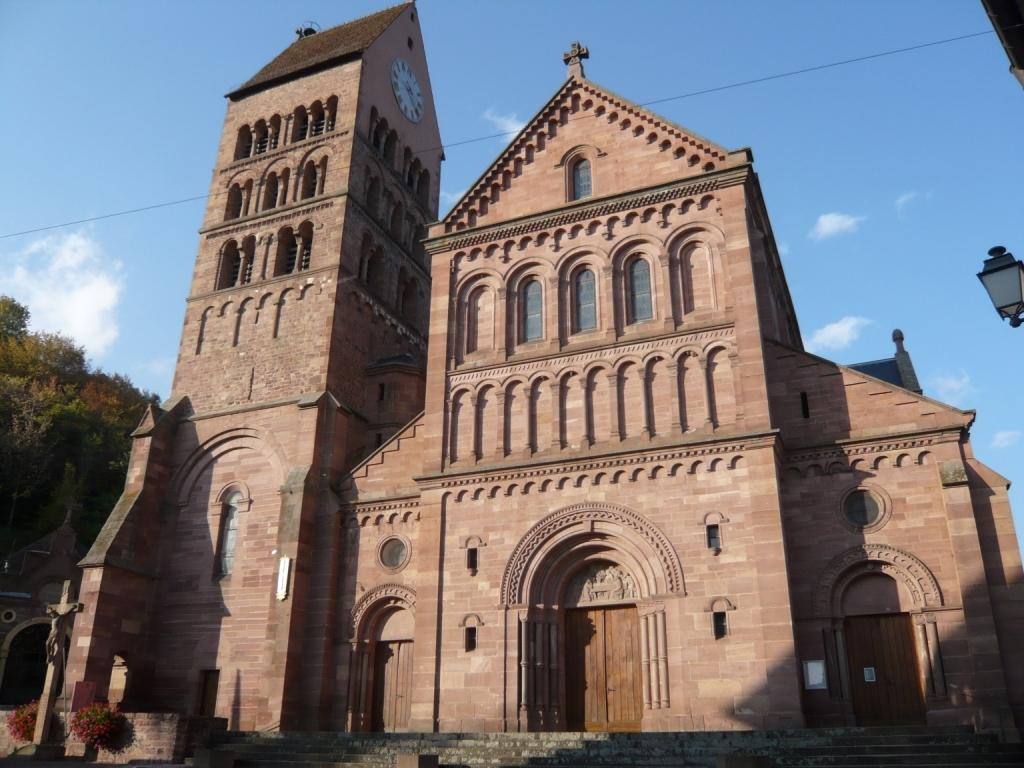What type of building is shown in the image? The building has arched windows and doors. What can be seen on the left side of the image? There are trees on the left side of the image. What is visible in the background of the image? The sky is visible in the background of the image. How can one access the building? There are steps in the front of the building. Can you tell me how many geese are standing on the steps in the image? There are no geese present in the image; the focus is on the building with arched windows and doors, trees on the left side, visible sky, and steps in the front. 